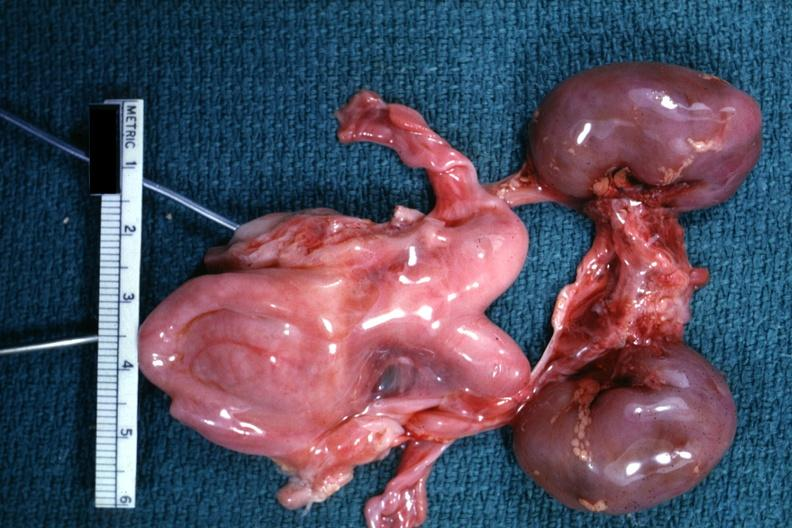where does this belong to?
Answer the question using a single word or phrase. Female reproductive system 